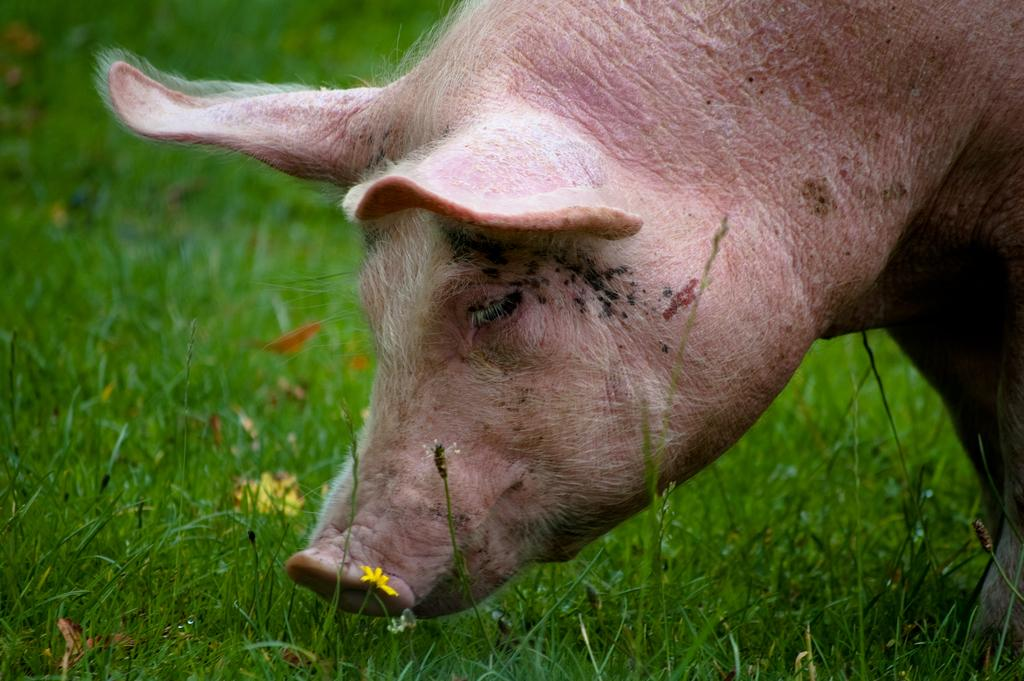What animal is present in the image? There is a pig in the image. Where is the pig located? The pig is on the grass. What type of bead is the pig wearing around its neck in the image? There is no bead present around the pig's neck in the image. What is the name of the pig in the image? The name of the pig is not mentioned in the image. 